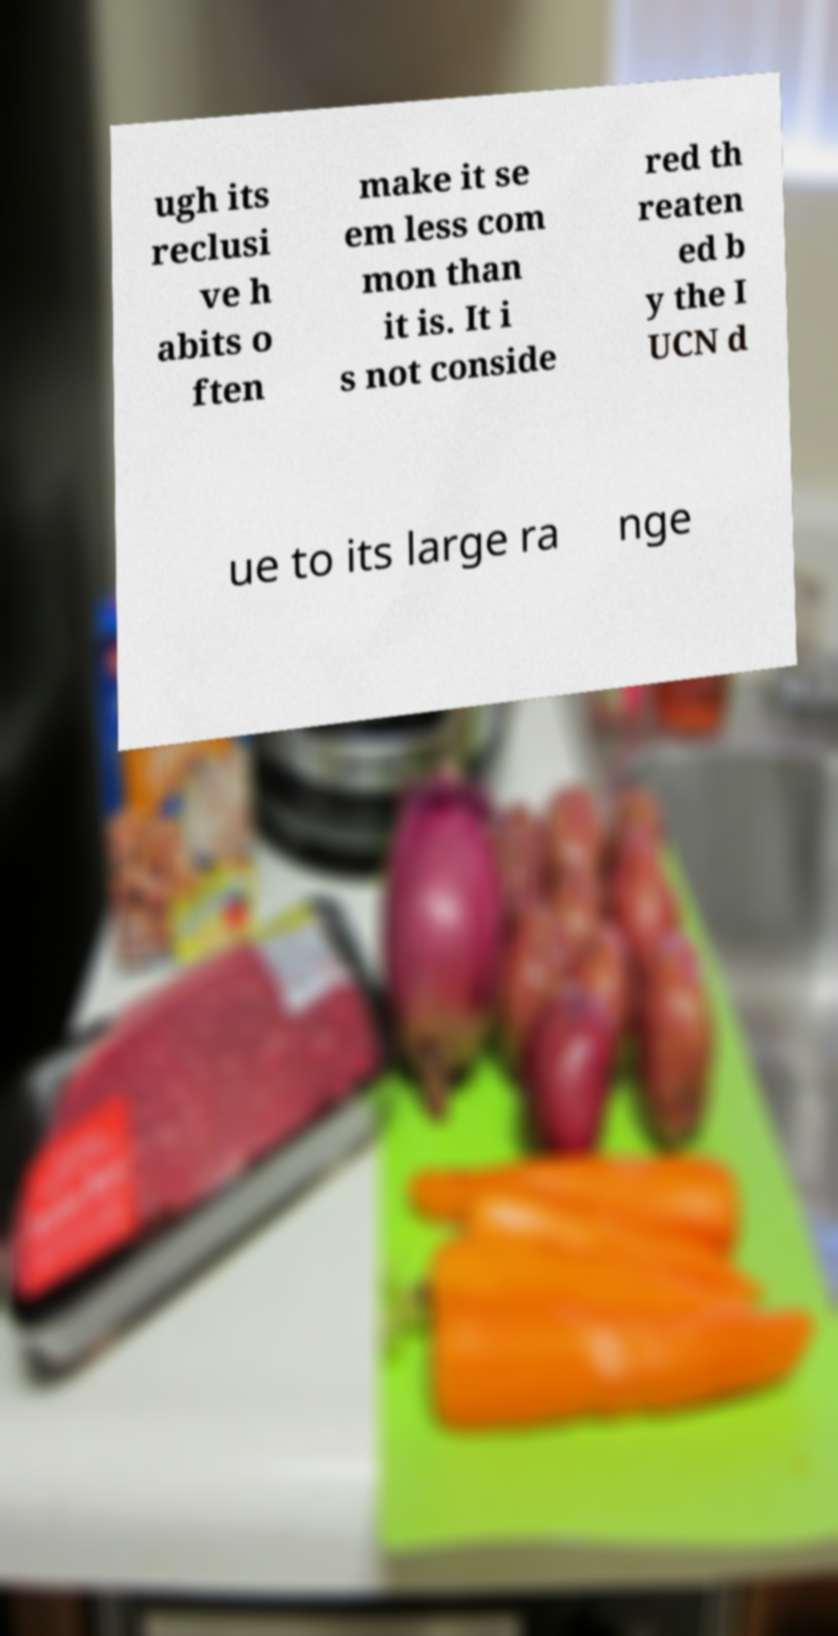Can you accurately transcribe the text from the provided image for me? ugh its reclusi ve h abits o ften make it se em less com mon than it is. It i s not conside red th reaten ed b y the I UCN d ue to its large ra nge 